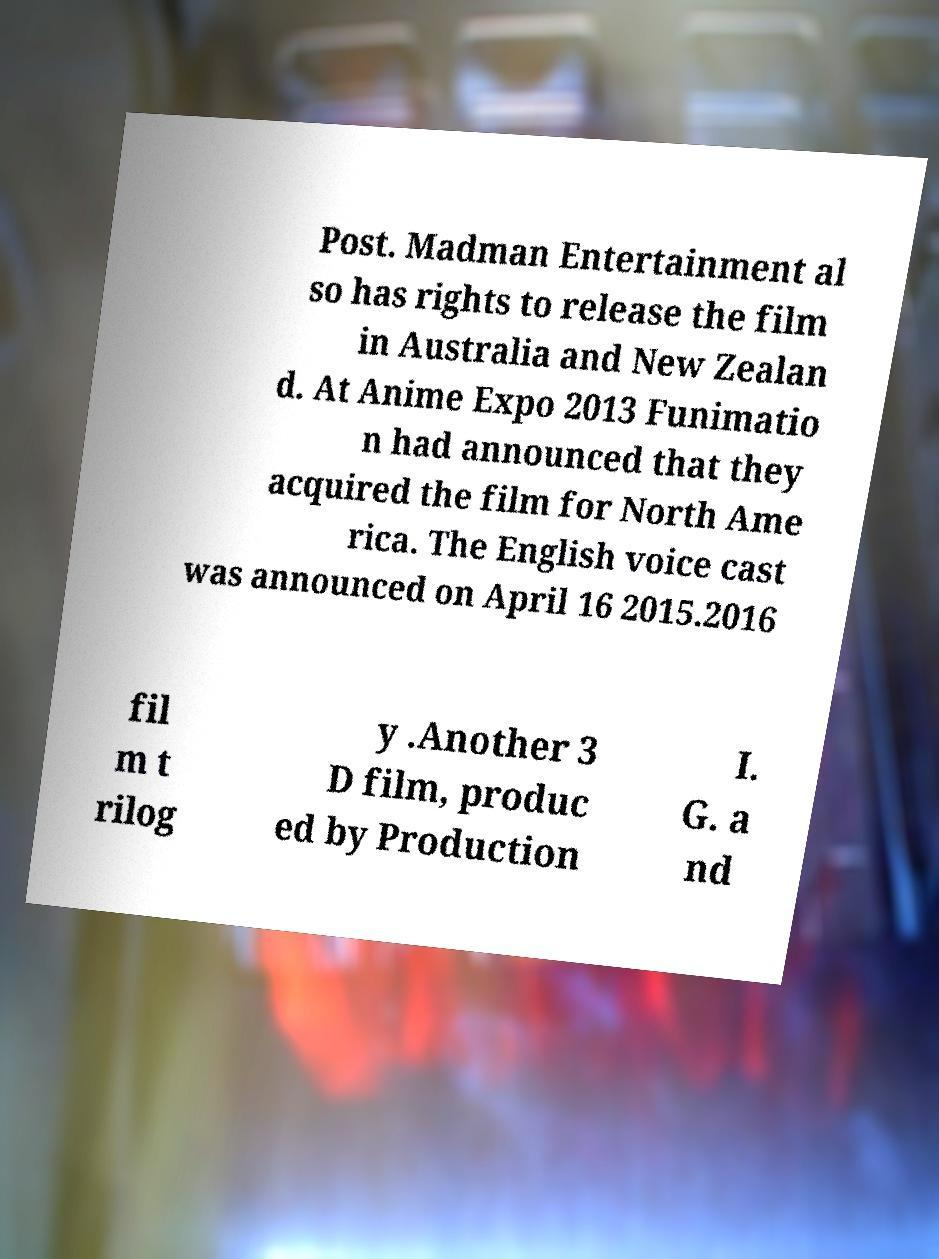There's text embedded in this image that I need extracted. Can you transcribe it verbatim? Post. Madman Entertainment al so has rights to release the film in Australia and New Zealan d. At Anime Expo 2013 Funimatio n had announced that they acquired the film for North Ame rica. The English voice cast was announced on April 16 2015.2016 fil m t rilog y .Another 3 D film, produc ed by Production I. G. a nd 